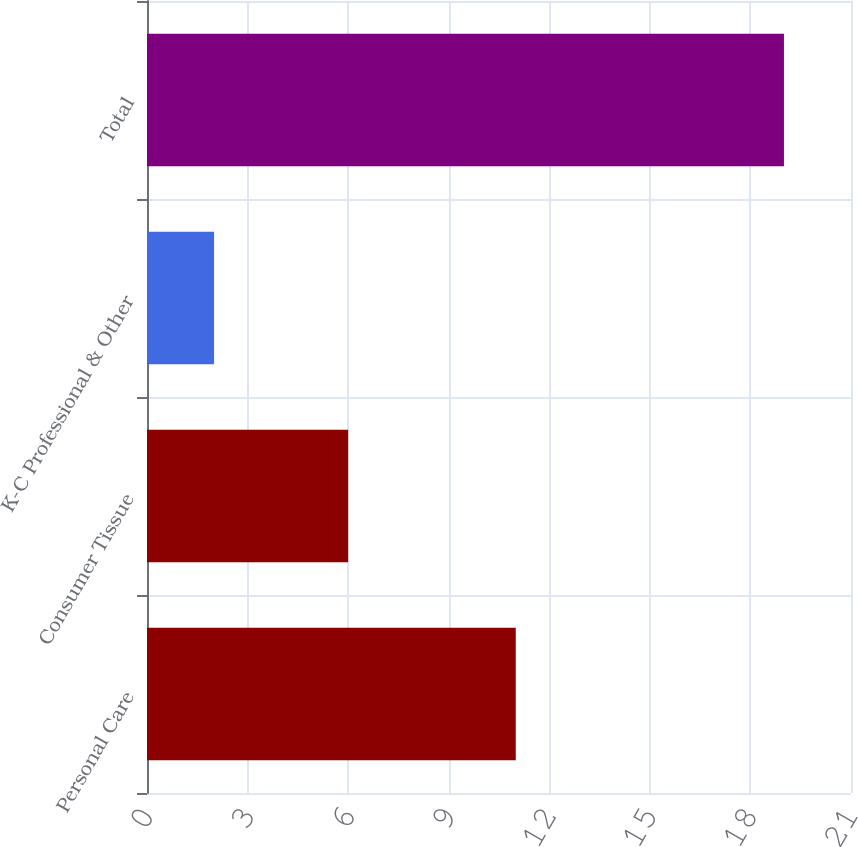<chart> <loc_0><loc_0><loc_500><loc_500><bar_chart><fcel>Personal Care<fcel>Consumer Tissue<fcel>K-C Professional & Other<fcel>Total<nl><fcel>11<fcel>6<fcel>2<fcel>19<nl></chart> 